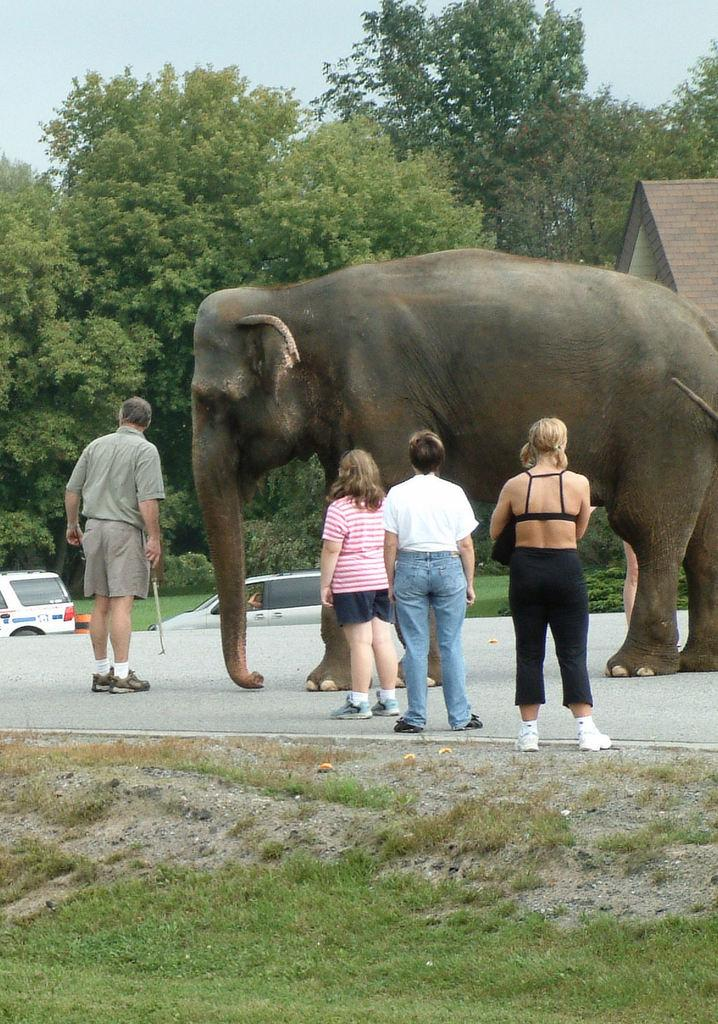What animal can be seen in the image? There is an elephant in the image. What else is present in the image besides the elephant? There is a group of people standing on the road, trees, and vehicles visible in the image. What type of crayon is the lawyer holding in the image? There is no lawyer or crayon present in the image. 